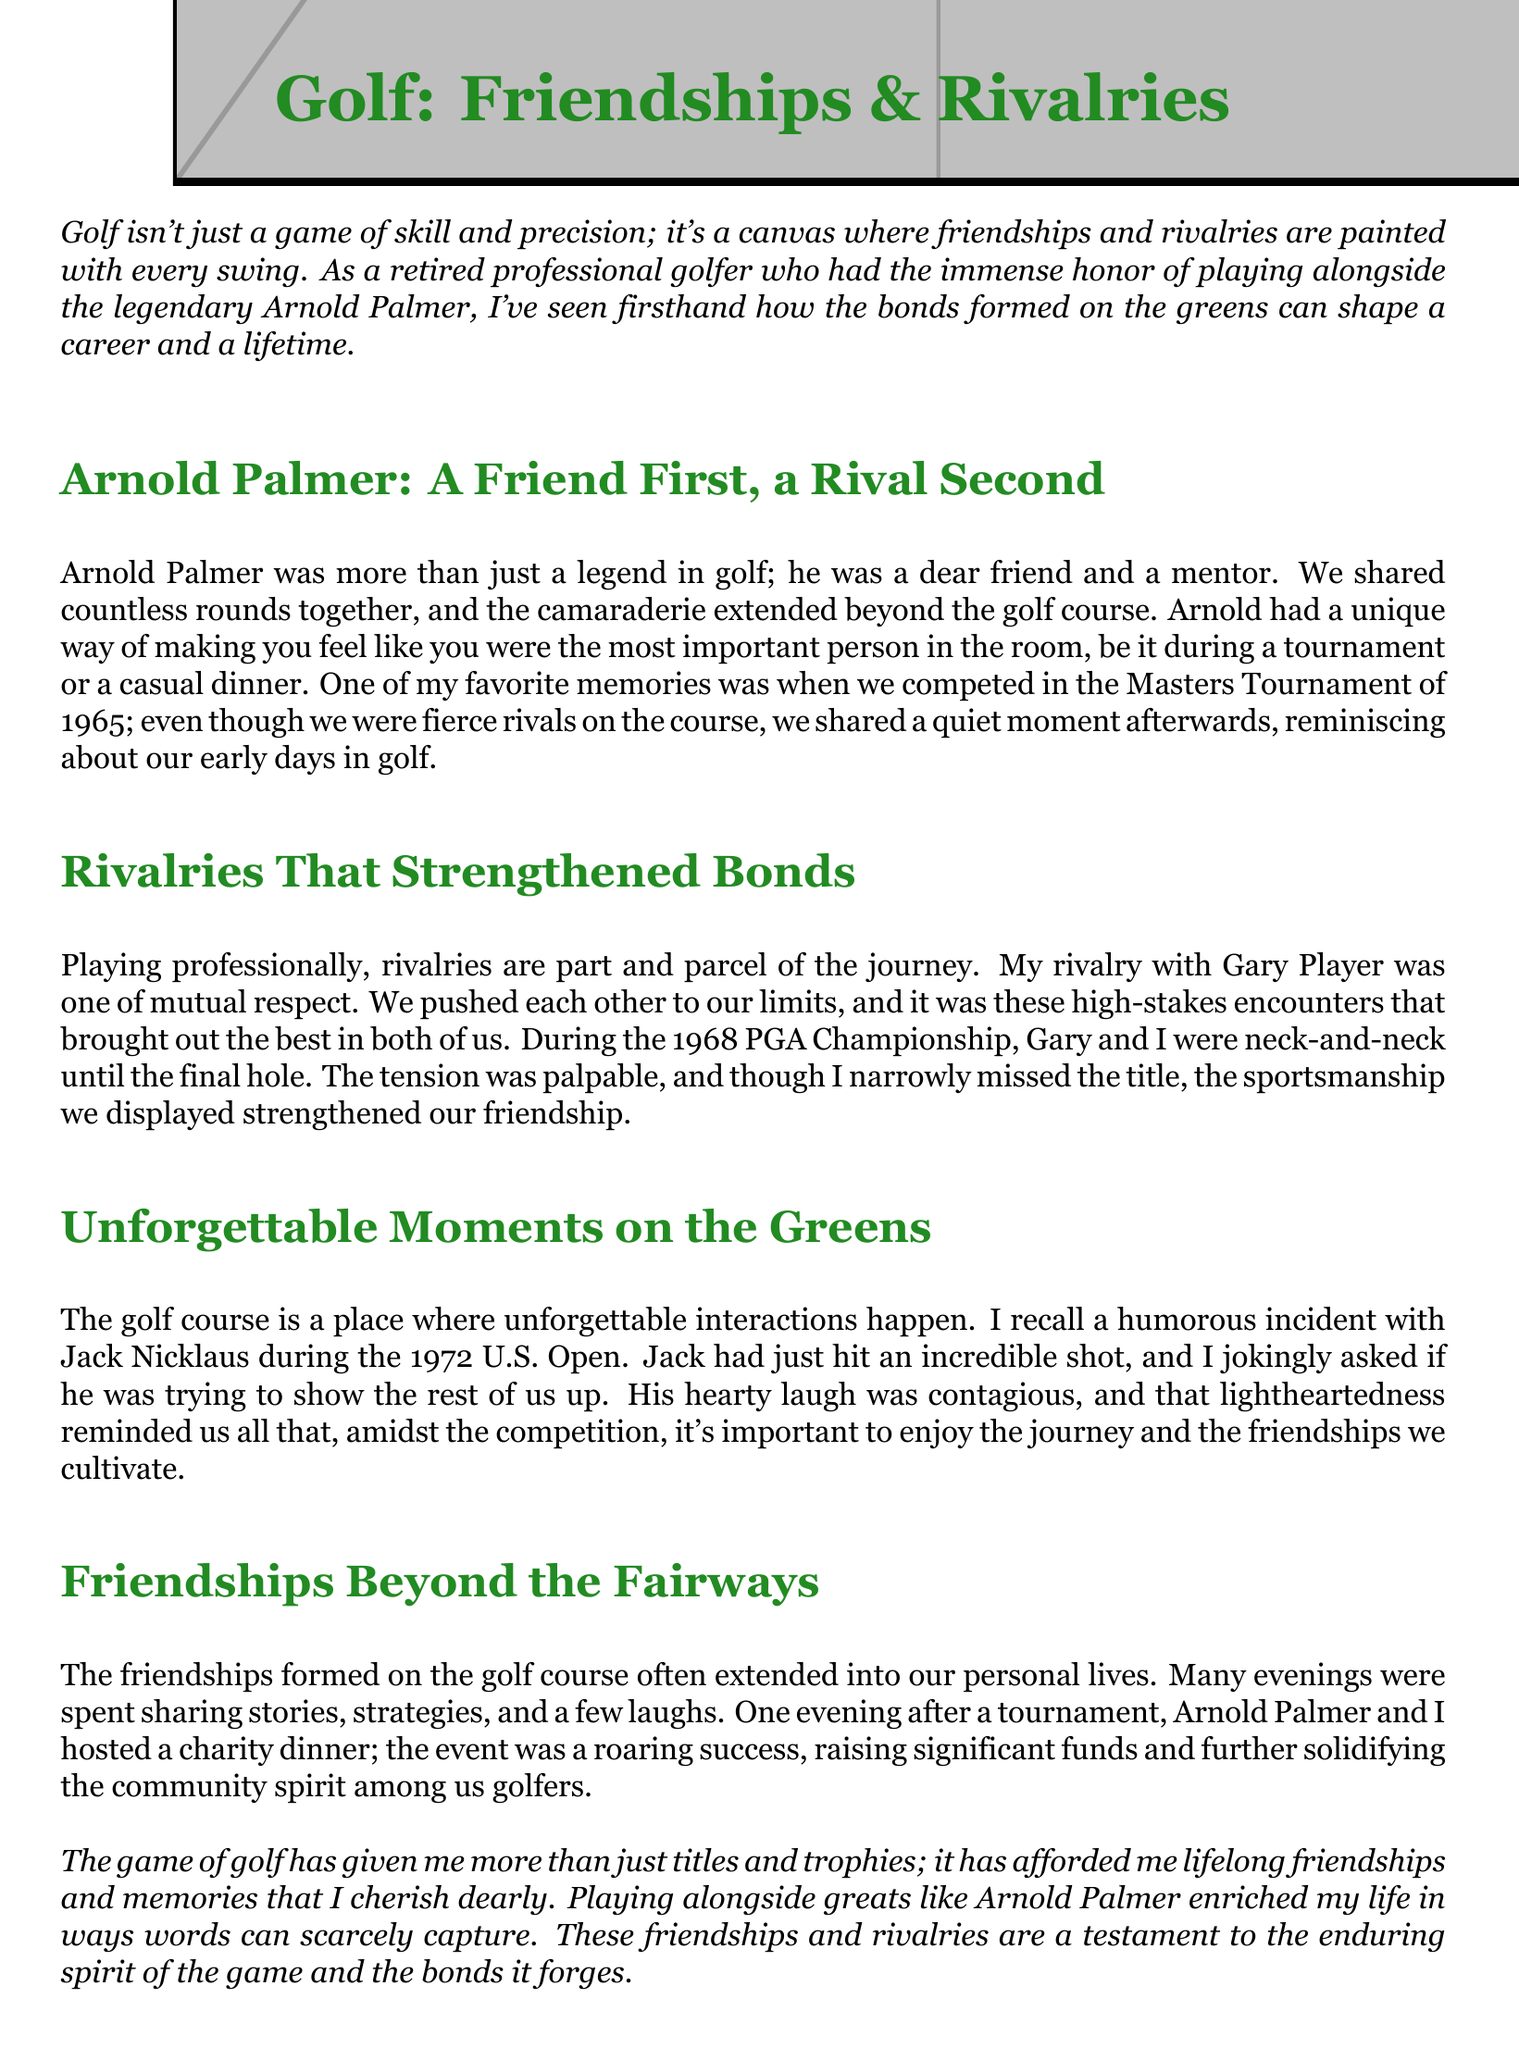What year did the Masters Tournament occur where Arnold Palmer and I reminisced? The document notes the Masters Tournament took place in 1965, during which a quiet moment was shared.
Answer: 1965 Who was my rival that I had mutual respect for? The document mentions Gary Player as the rival with whom I had a respectful rivalry that pushed us both.
Answer: Gary Player What significant charitable activity did Arnold Palmer and I host together? The document states that the charity dinner we hosted raised significant funds, fostering community spirit among golfers.
Answer: Charity dinner In which championship did Gary Player and I have a close competition? According to the document, the neck-and-neck competition occurred during the 1968 PGA Championship.
Answer: 1968 PGA Championship What humorous incident involved Jack Nicklaus during the U.S. Open? The document recounts a joking question I asked Jack Nicklaus about showing us up after an incredible shot at the 1972 U.S. Open.
Answer: Showing us up What overall impact did the game of golf have on my life according to the conclusion? The document concludes that golf brought lifelong friendships and cherished memories.
Answer: Lifelong friendships and cherished memories 